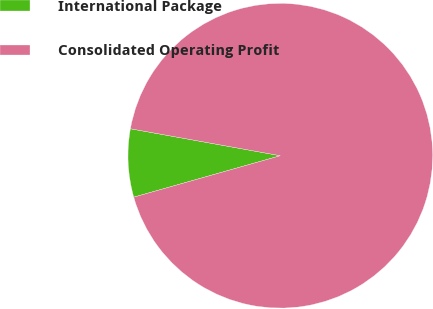<chart> <loc_0><loc_0><loc_500><loc_500><pie_chart><fcel>International Package<fcel>Consolidated Operating Profit<nl><fcel>7.22%<fcel>92.78%<nl></chart> 